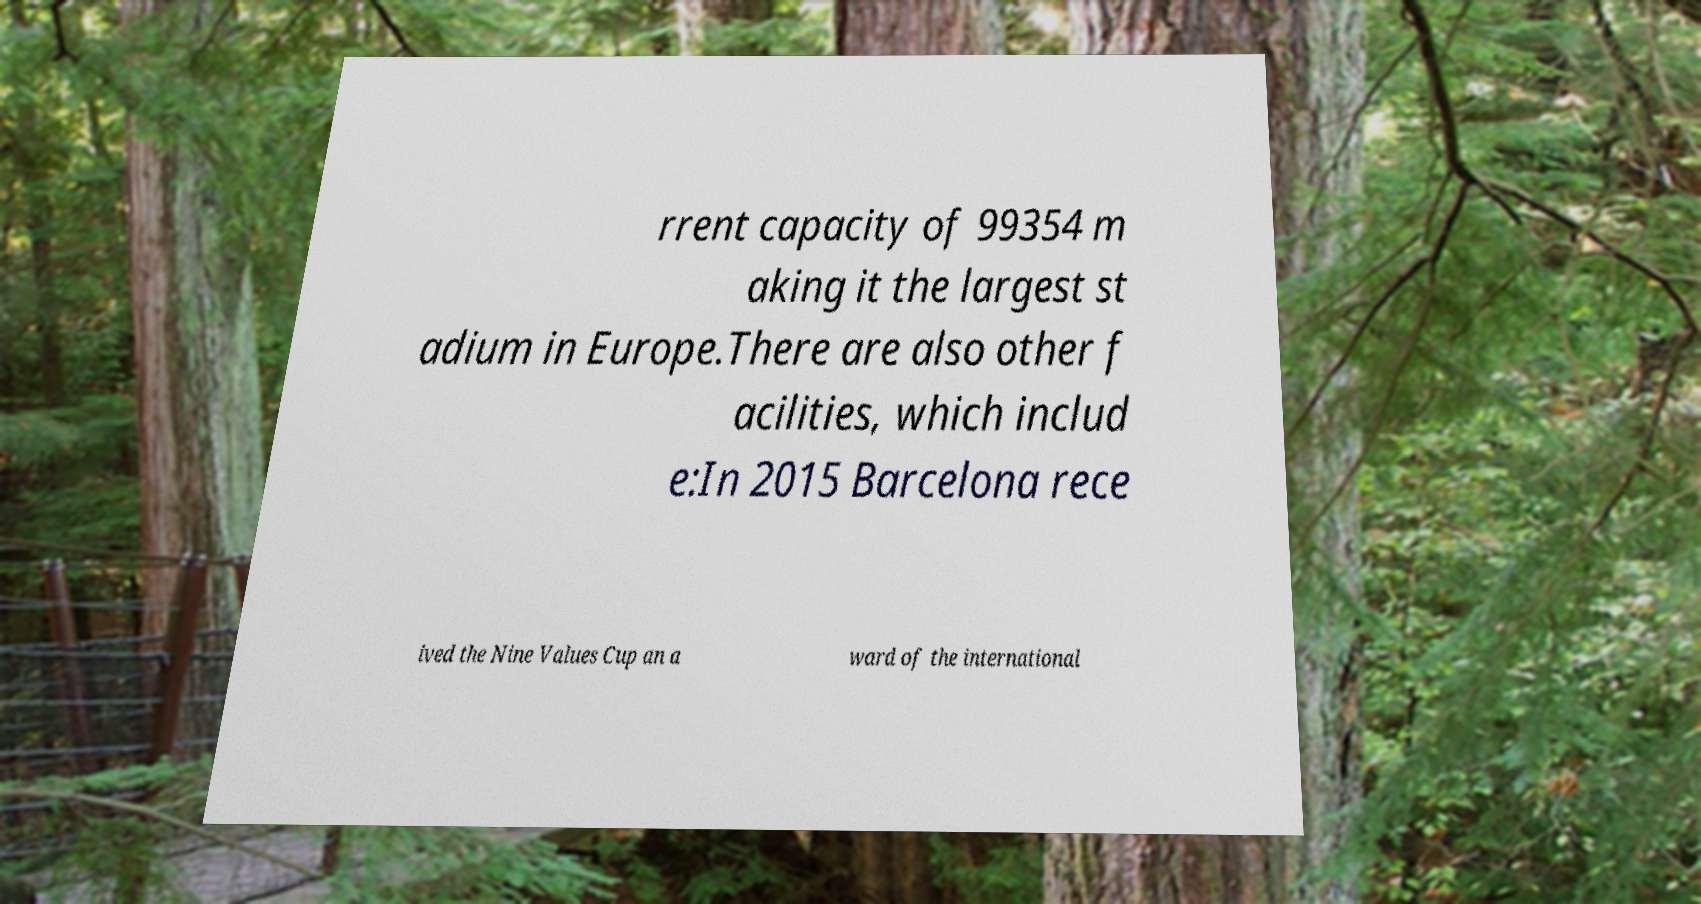There's text embedded in this image that I need extracted. Can you transcribe it verbatim? rrent capacity of 99354 m aking it the largest st adium in Europe.There are also other f acilities, which includ e:In 2015 Barcelona rece ived the Nine Values Cup an a ward of the international 